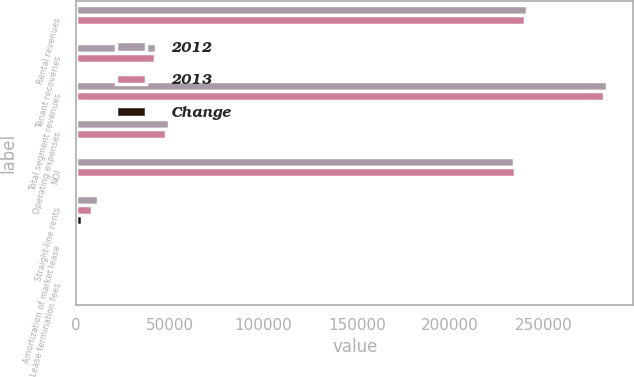Convert chart to OTSL. <chart><loc_0><loc_0><loc_500><loc_500><stacked_bar_chart><ecel><fcel>Rental revenues<fcel>Tenant recoveries<fcel>Total segment revenues<fcel>Operating expenses<fcel>NOI<fcel>Straight-line rents<fcel>Amortization of market lease<fcel>Lease termination fees<nl><fcel>2012<fcel>240777<fcel>42975<fcel>283752<fcel>49636<fcel>234116<fcel>11604<fcel>112<fcel>194<nl><fcel>2013<fcel>240145<fcel>42164<fcel>282309<fcel>47914<fcel>234395<fcel>8590<fcel>462<fcel>175<nl><fcel>Change<fcel>632<fcel>811<fcel>1443<fcel>1722<fcel>279<fcel>3014<fcel>350<fcel>19<nl></chart> 